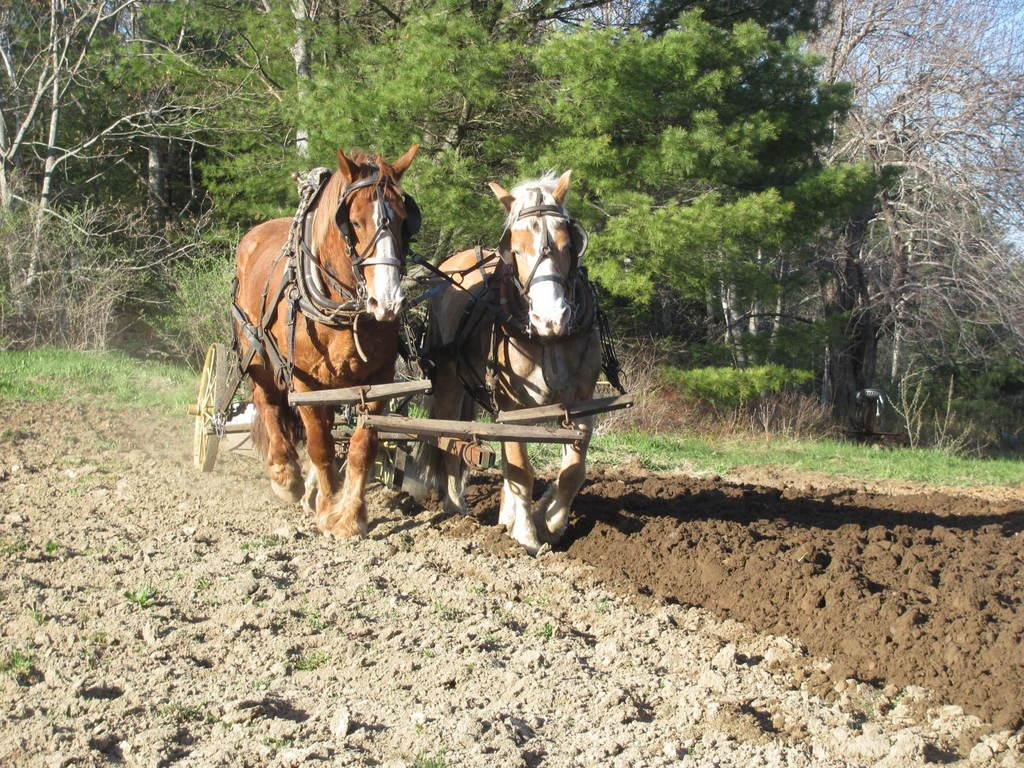How many horses are in the image? There are two horses in the image. What can be seen in the background of the image? There are trees in the background of the image. What is the name of the horse on the left side of the image? The provided facts do not mention any names for the horses, so we cannot determine the name of the horse on the left side of the image. 